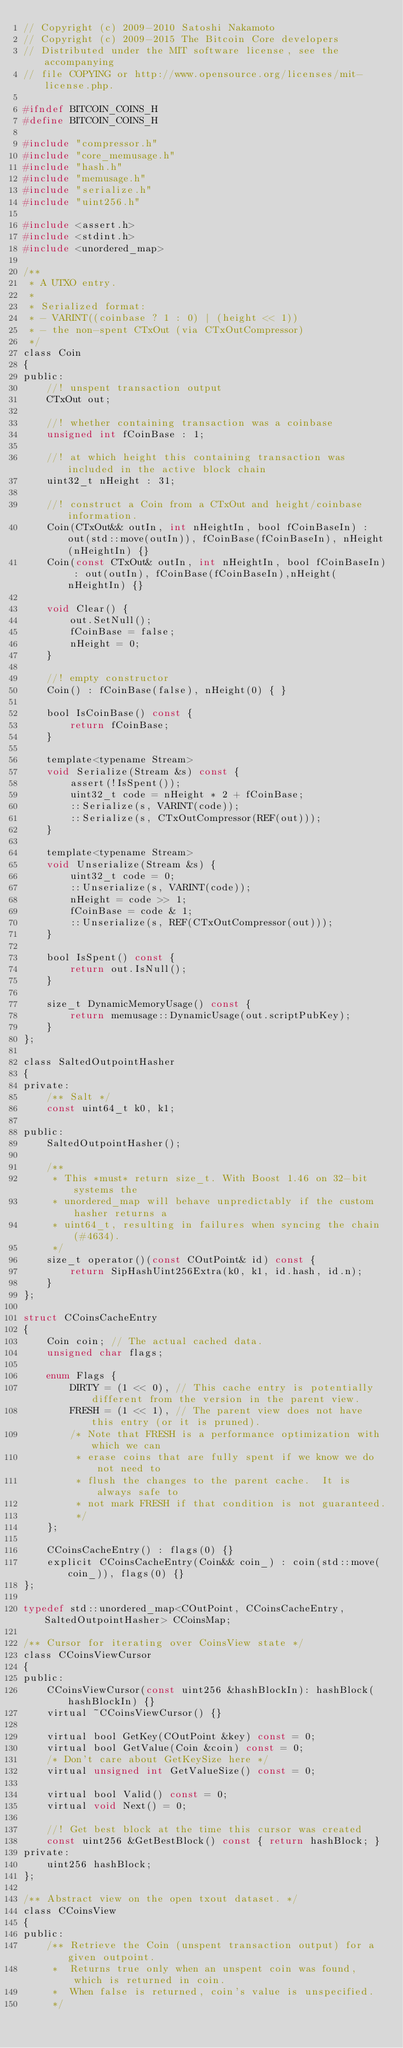<code> <loc_0><loc_0><loc_500><loc_500><_C_>// Copyright (c) 2009-2010 Satoshi Nakamoto
// Copyright (c) 2009-2015 The Bitcoin Core developers
// Distributed under the MIT software license, see the accompanying
// file COPYING or http://www.opensource.org/licenses/mit-license.php.

#ifndef BITCOIN_COINS_H
#define BITCOIN_COINS_H

#include "compressor.h"
#include "core_memusage.h"
#include "hash.h"
#include "memusage.h"
#include "serialize.h"
#include "uint256.h"

#include <assert.h>
#include <stdint.h>
#include <unordered_map>

/**
 * A UTXO entry.
 *
 * Serialized format:
 * - VARINT((coinbase ? 1 : 0) | (height << 1))
 * - the non-spent CTxOut (via CTxOutCompressor)
 */
class Coin
{
public:
    //! unspent transaction output
    CTxOut out;

    //! whether containing transaction was a coinbase
    unsigned int fCoinBase : 1;

    //! at which height this containing transaction was included in the active block chain
    uint32_t nHeight : 31;

    //! construct a Coin from a CTxOut and height/coinbase information.
    Coin(CTxOut&& outIn, int nHeightIn, bool fCoinBaseIn) : out(std::move(outIn)), fCoinBase(fCoinBaseIn), nHeight(nHeightIn) {}
    Coin(const CTxOut& outIn, int nHeightIn, bool fCoinBaseIn) : out(outIn), fCoinBase(fCoinBaseIn),nHeight(nHeightIn) {}

    void Clear() {
        out.SetNull();
        fCoinBase = false;
        nHeight = 0;
    }

    //! empty constructor
    Coin() : fCoinBase(false), nHeight(0) { }

    bool IsCoinBase() const {
        return fCoinBase;
    }

    template<typename Stream>
    void Serialize(Stream &s) const {
        assert(!IsSpent());
        uint32_t code = nHeight * 2 + fCoinBase;
        ::Serialize(s, VARINT(code));
        ::Serialize(s, CTxOutCompressor(REF(out)));
    }

    template<typename Stream>
    void Unserialize(Stream &s) {
        uint32_t code = 0;
        ::Unserialize(s, VARINT(code));
        nHeight = code >> 1;
        fCoinBase = code & 1;
        ::Unserialize(s, REF(CTxOutCompressor(out)));
    }

    bool IsSpent() const {
        return out.IsNull();
    }

    size_t DynamicMemoryUsage() const {
        return memusage::DynamicUsage(out.scriptPubKey);
    }
};

class SaltedOutpointHasher
{
private:
    /** Salt */
    const uint64_t k0, k1;

public:
    SaltedOutpointHasher();

    /**
     * This *must* return size_t. With Boost 1.46 on 32-bit systems the
     * unordered_map will behave unpredictably if the custom hasher returns a
     * uint64_t, resulting in failures when syncing the chain (#4634).
     */
    size_t operator()(const COutPoint& id) const {
        return SipHashUint256Extra(k0, k1, id.hash, id.n);
    }
};

struct CCoinsCacheEntry
{
    Coin coin; // The actual cached data.
    unsigned char flags;

    enum Flags {
        DIRTY = (1 << 0), // This cache entry is potentially different from the version in the parent view.
        FRESH = (1 << 1), // The parent view does not have this entry (or it is pruned).
        /* Note that FRESH is a performance optimization with which we can
         * erase coins that are fully spent if we know we do not need to
         * flush the changes to the parent cache.  It is always safe to
         * not mark FRESH if that condition is not guaranteed.
         */
    };

    CCoinsCacheEntry() : flags(0) {}
    explicit CCoinsCacheEntry(Coin&& coin_) : coin(std::move(coin_)), flags(0) {}
};

typedef std::unordered_map<COutPoint, CCoinsCacheEntry, SaltedOutpointHasher> CCoinsMap;

/** Cursor for iterating over CoinsView state */
class CCoinsViewCursor
{
public:
    CCoinsViewCursor(const uint256 &hashBlockIn): hashBlock(hashBlockIn) {}
    virtual ~CCoinsViewCursor() {}

    virtual bool GetKey(COutPoint &key) const = 0;
    virtual bool GetValue(Coin &coin) const = 0;
    /* Don't care about GetKeySize here */
    virtual unsigned int GetValueSize() const = 0;

    virtual bool Valid() const = 0;
    virtual void Next() = 0;

    //! Get best block at the time this cursor was created
    const uint256 &GetBestBlock() const { return hashBlock; }
private:
    uint256 hashBlock;
};

/** Abstract view on the open txout dataset. */
class CCoinsView
{
public:
    /** Retrieve the Coin (unspent transaction output) for a given outpoint.
     *  Returns true only when an unspent coin was found, which is returned in coin.
     *  When false is returned, coin's value is unspecified.
     */</code> 